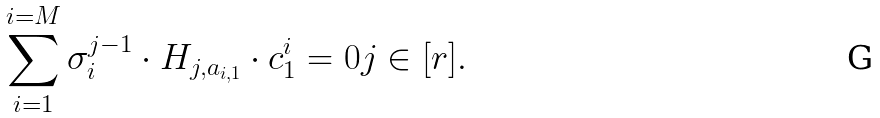Convert formula to latex. <formula><loc_0><loc_0><loc_500><loc_500>\sum _ { i = 1 } ^ { i = M } \sigma _ { i } ^ { j - 1 } \cdot H _ { j , a _ { i , 1 } } \cdot c ^ { i } _ { 1 } = 0 j \in [ r ] .</formula> 